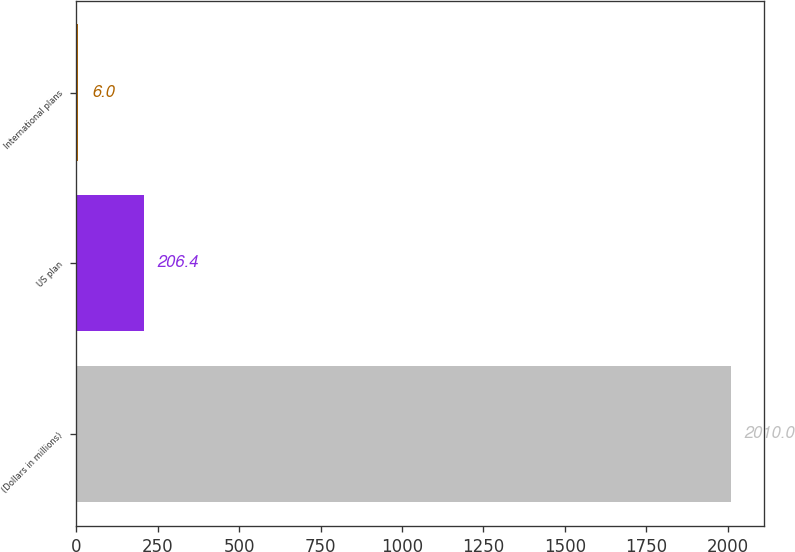Convert chart to OTSL. <chart><loc_0><loc_0><loc_500><loc_500><bar_chart><fcel>(Dollars in millions)<fcel>US plan<fcel>International plans<nl><fcel>2010<fcel>206.4<fcel>6<nl></chart> 